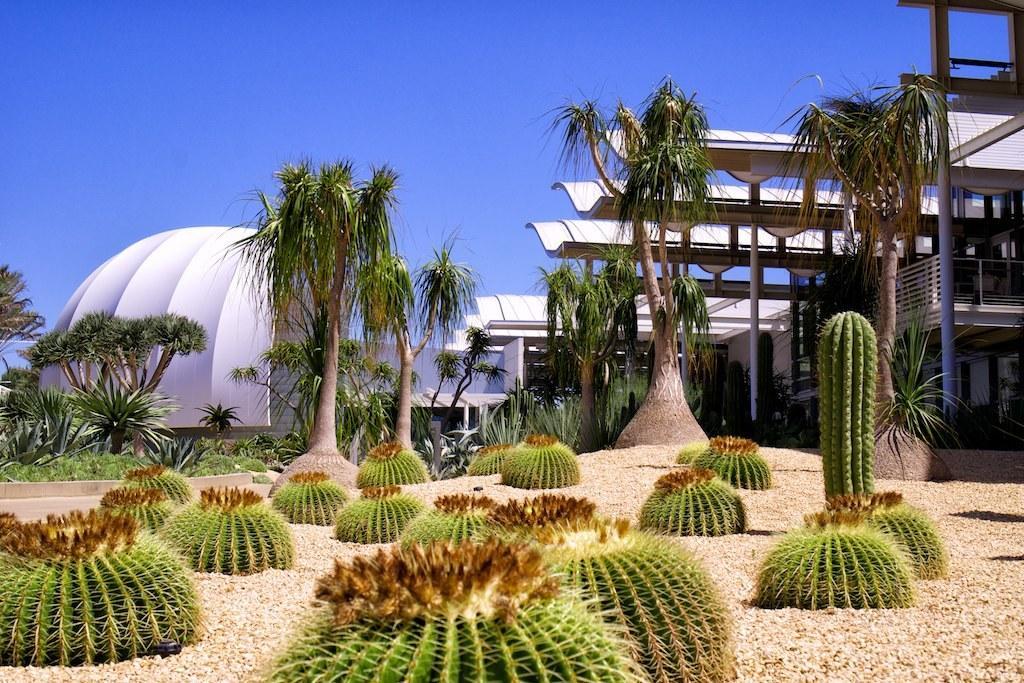Could you give a brief overview of what you see in this image? This is an outside view. At the bottom of the image I can see few cactus plants on the ground. In the background there are some trees and buildings. At the top, I can see the sky. 